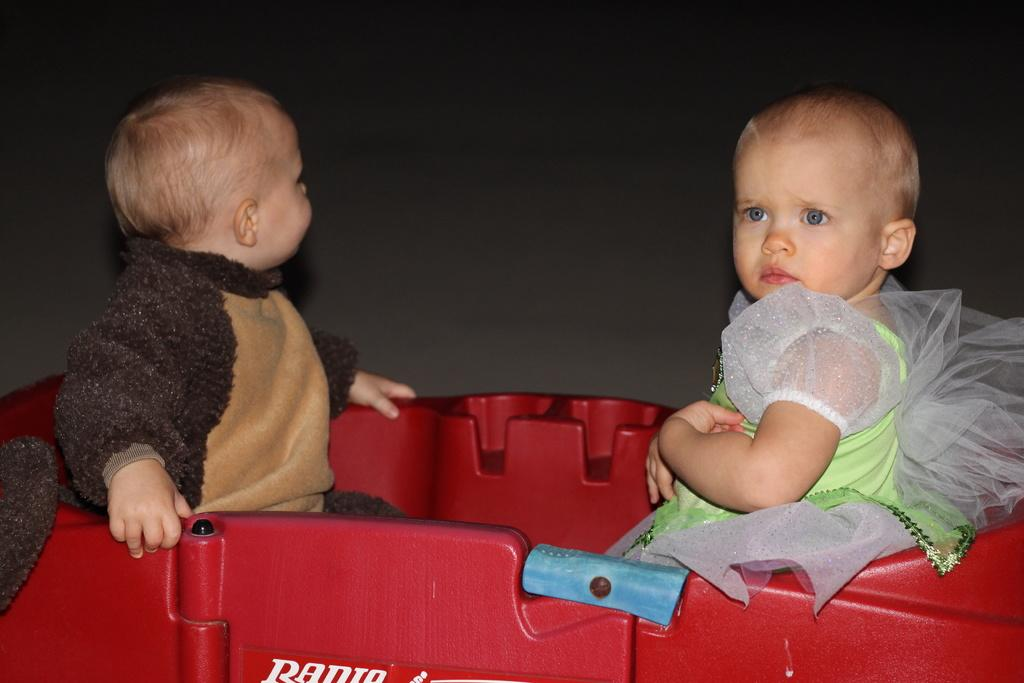How many kids are in the image? There are two kids sitting in the center of the image. What can be seen in the background of the image? There is a wall in the background of the image. What type of shoe is the country wearing in the image? There is no country or shoe present in the image. How many cars are visible in the image? There are no cars visible in the image; it only features two kids sitting in the center and a wall in the background. 